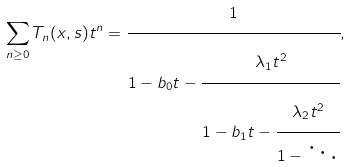<formula> <loc_0><loc_0><loc_500><loc_500>\sum _ { n \geq 0 } T _ { n } ( x , s ) t ^ { n } = \cfrac { 1 } { 1 - b _ { 0 } t - \cfrac { \lambda _ { 1 } t ^ { 2 } } { 1 - b _ { 1 } t - \cfrac { \lambda _ { 2 } t ^ { 2 } } { 1 - \ddots } } } ,</formula> 